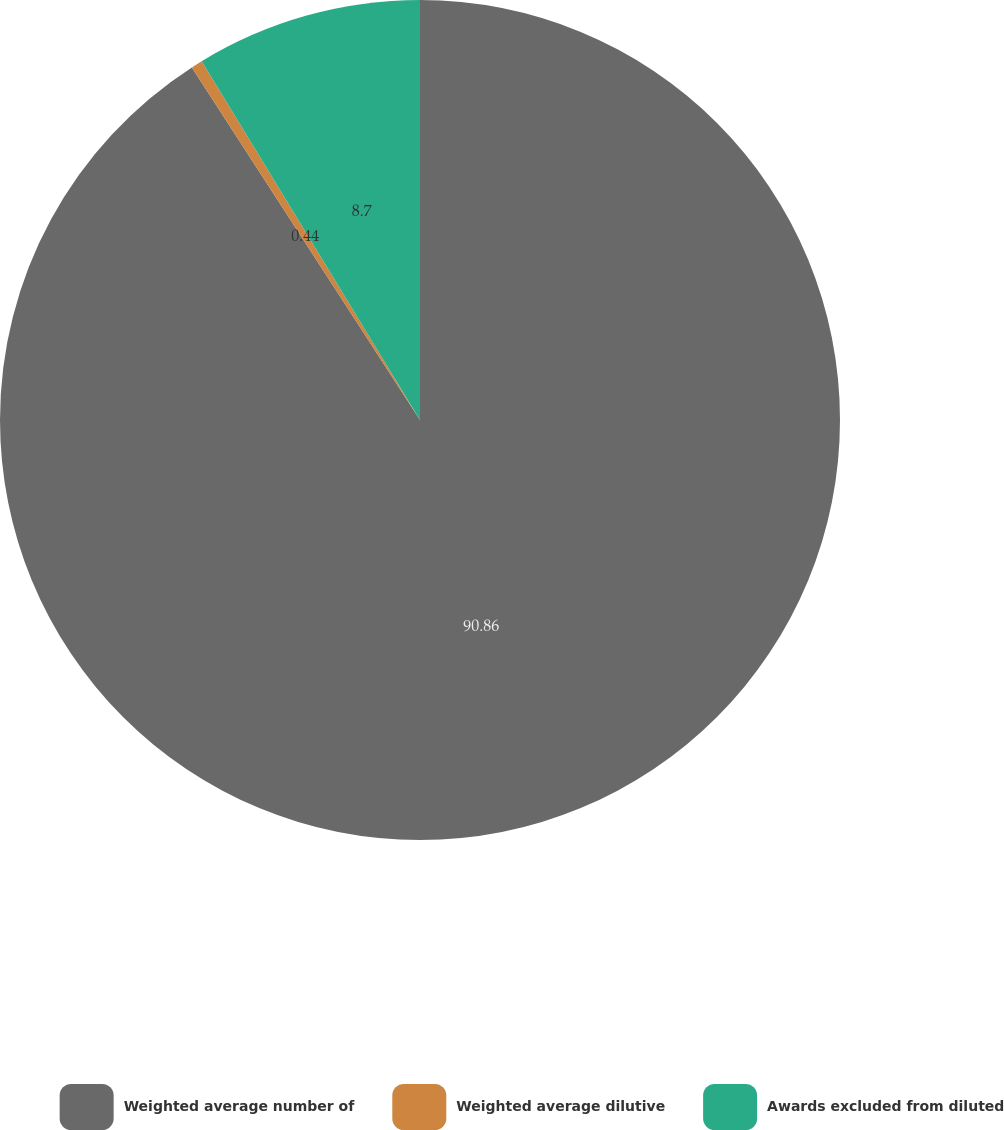Convert chart. <chart><loc_0><loc_0><loc_500><loc_500><pie_chart><fcel>Weighted average number of<fcel>Weighted average dilutive<fcel>Awards excluded from diluted<nl><fcel>90.86%<fcel>0.44%<fcel>8.7%<nl></chart> 